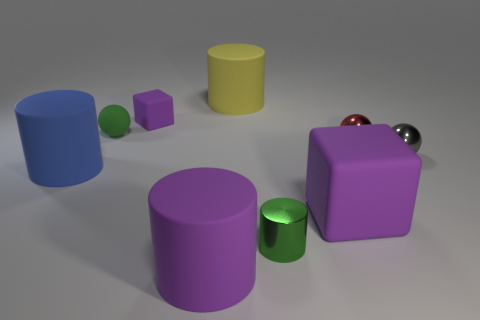What is the color of the large rubber cylinder right of the matte thing in front of the matte block that is in front of the blue rubber object?
Keep it short and to the point. Yellow. There is a metallic thing in front of the big blue matte object; is there a tiny cylinder left of it?
Give a very brief answer. No. There is a large purple thing that is to the right of the big yellow object; is its shape the same as the tiny purple thing?
Provide a short and direct response. Yes. Are there any other things that have the same shape as the small purple object?
Offer a very short reply. Yes. How many blocks are either large blue objects or small gray objects?
Keep it short and to the point. 0. What number of red metallic spheres are there?
Provide a succinct answer. 1. There is a shiny sphere that is on the left side of the ball in front of the red ball; how big is it?
Your answer should be compact. Small. How many other objects are there of the same size as the green rubber ball?
Keep it short and to the point. 4. There is a blue matte cylinder; what number of green objects are on the left side of it?
Ensure brevity in your answer.  0. What is the size of the green cylinder?
Keep it short and to the point. Small. 